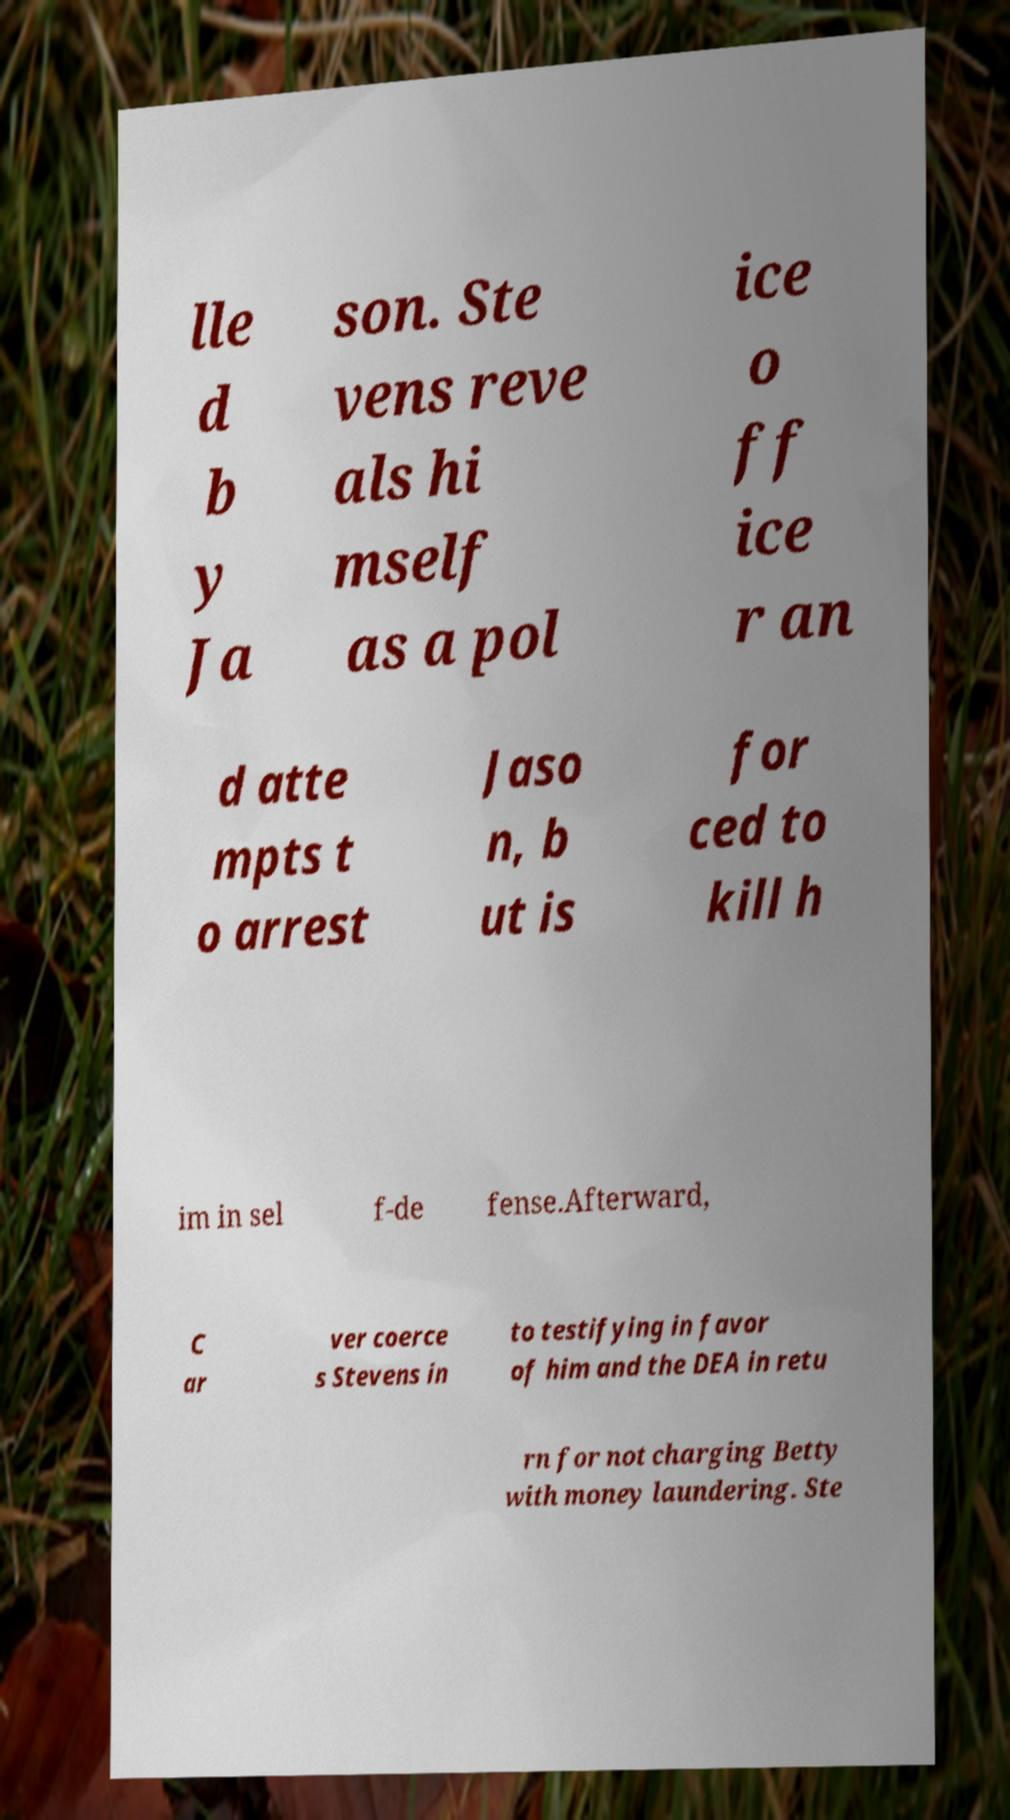What messages or text are displayed in this image? I need them in a readable, typed format. lle d b y Ja son. Ste vens reve als hi mself as a pol ice o ff ice r an d atte mpts t o arrest Jaso n, b ut is for ced to kill h im in sel f-de fense.Afterward, C ar ver coerce s Stevens in to testifying in favor of him and the DEA in retu rn for not charging Betty with money laundering. Ste 